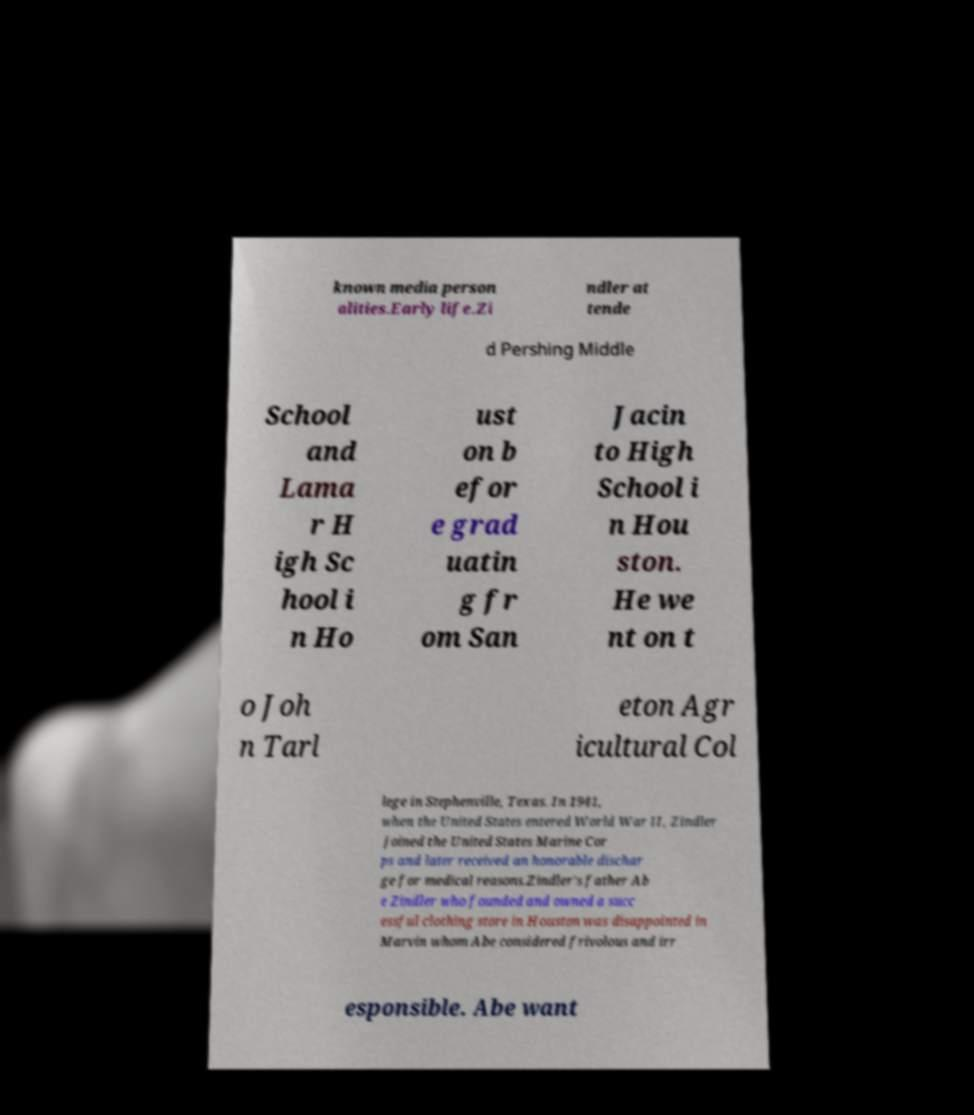For documentation purposes, I need the text within this image transcribed. Could you provide that? known media person alities.Early life.Zi ndler at tende d Pershing Middle School and Lama r H igh Sc hool i n Ho ust on b efor e grad uatin g fr om San Jacin to High School i n Hou ston. He we nt on t o Joh n Tarl eton Agr icultural Col lege in Stephenville, Texas. In 1941, when the United States entered World War II, Zindler joined the United States Marine Cor ps and later received an honorable dischar ge for medical reasons.Zindler's father Ab e Zindler who founded and owned a succ essful clothing store in Houston was disappointed in Marvin whom Abe considered frivolous and irr esponsible. Abe want 